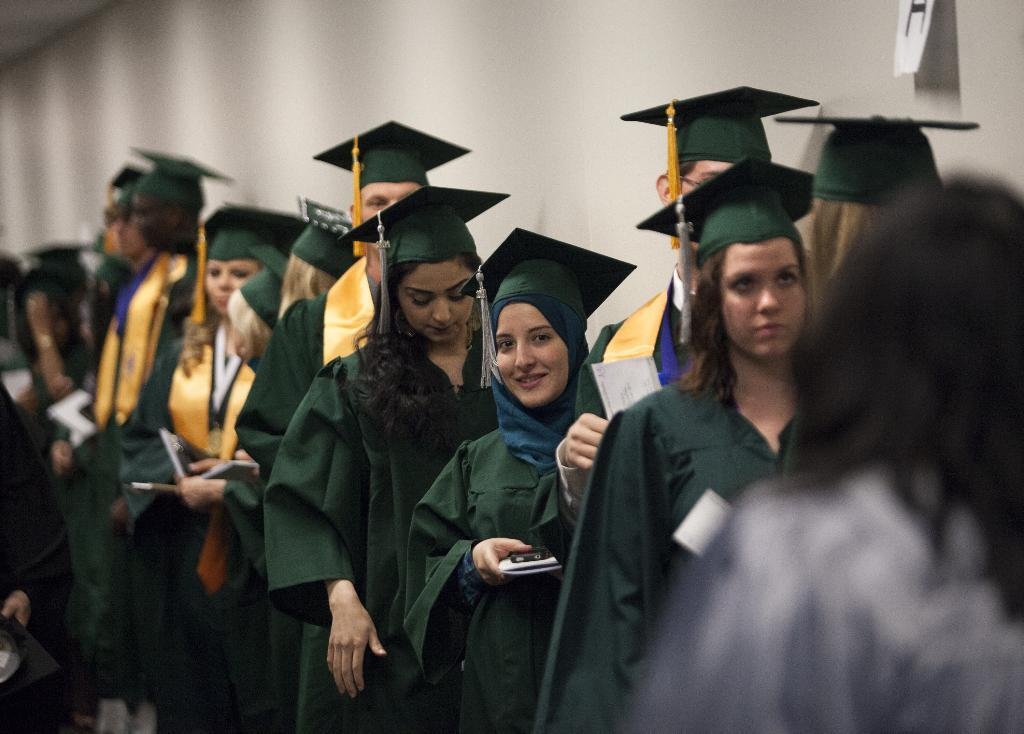What are the people in the image doing? The people in the image are holding a pen and a paper. What color is the object in the image? There is a black color object in the image. What can be seen in the background of the image? There is a wall in the background of the image. Is there any paper attached to the wall in the image? Yes, there is a paper attached to the wall in the image. What type of sofa can be seen in the image? There is no sofa present in the image. What educational level do the people in the image have? The image does not provide any information about the educational level of the people. 